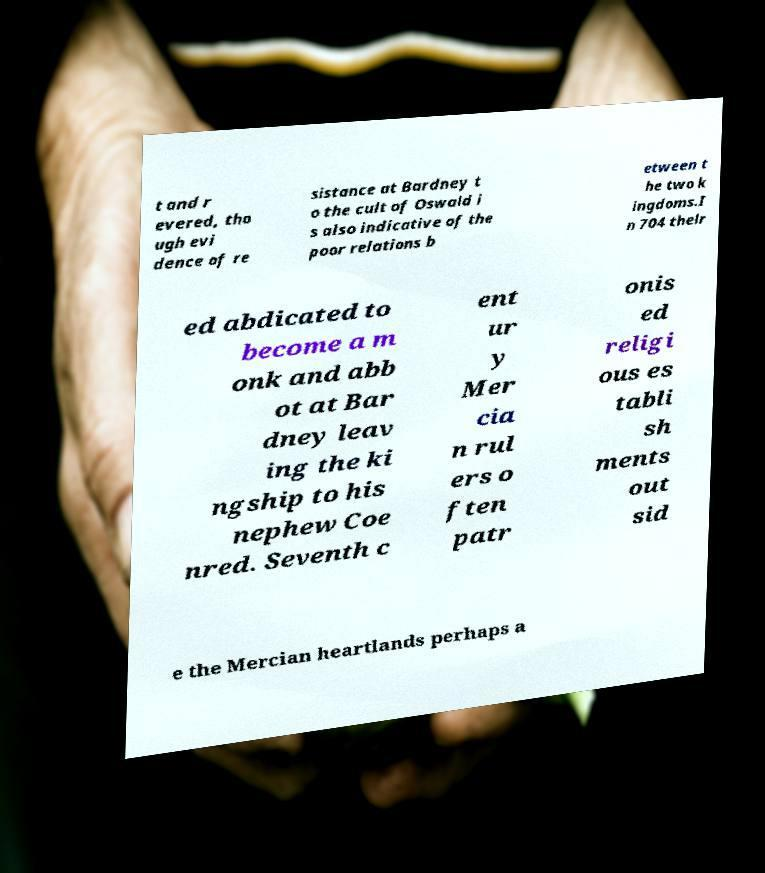Can you read and provide the text displayed in the image?This photo seems to have some interesting text. Can you extract and type it out for me? t and r evered, tho ugh evi dence of re sistance at Bardney t o the cult of Oswald i s also indicative of the poor relations b etween t he two k ingdoms.I n 704 thelr ed abdicated to become a m onk and abb ot at Bar dney leav ing the ki ngship to his nephew Coe nred. Seventh c ent ur y Mer cia n rul ers o ften patr onis ed religi ous es tabli sh ments out sid e the Mercian heartlands perhaps a 